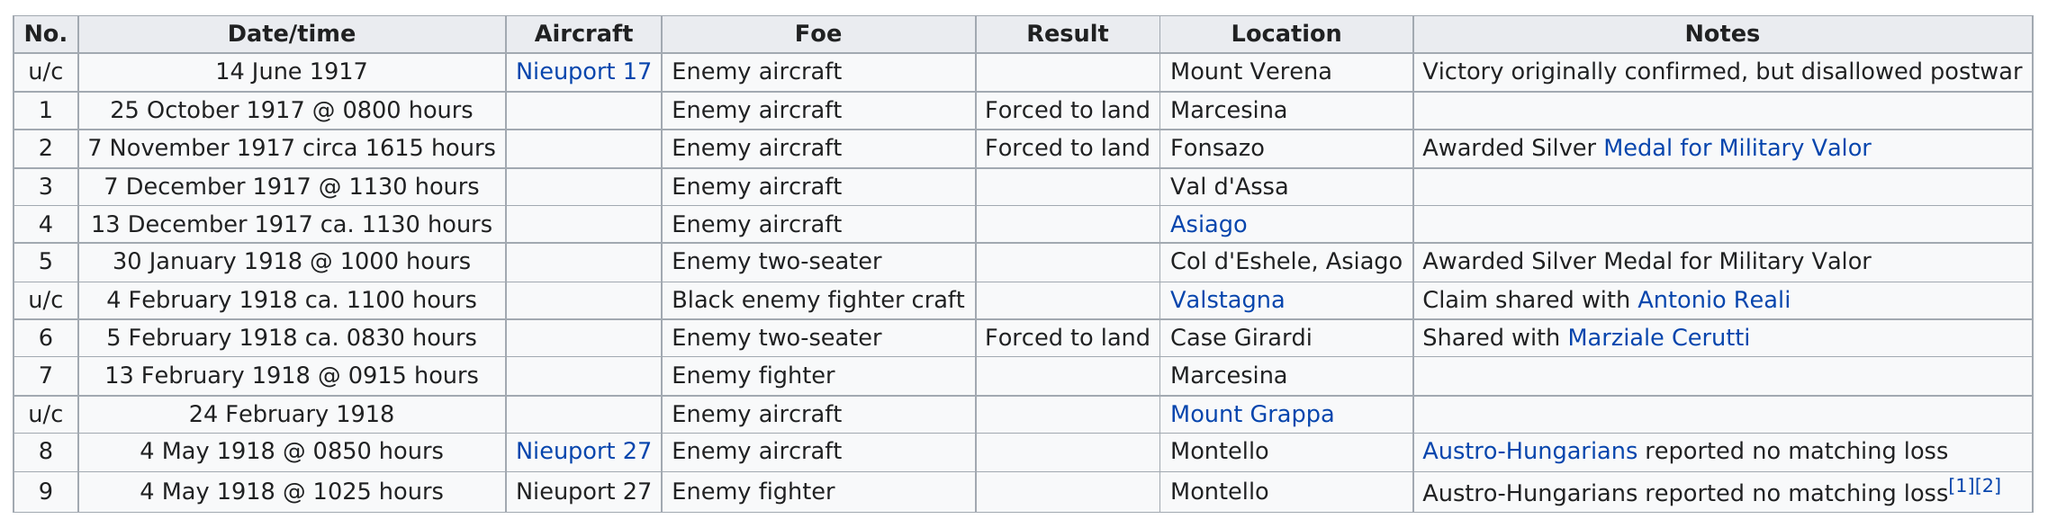Specify some key components in this picture. The last battle took place on May 4, 1918, at 10:25 a.m. The list includes the Nieuport 17 and the Nieuport 27 aircraft. The number of enemy aircraft is greater than the combined number of foes, making it a clear victory for us. During the specified time period, there were a total of 7 consecutive victories that involved an enemy aircraft as the opponent. At least 3 aircrafts were forced to land. 